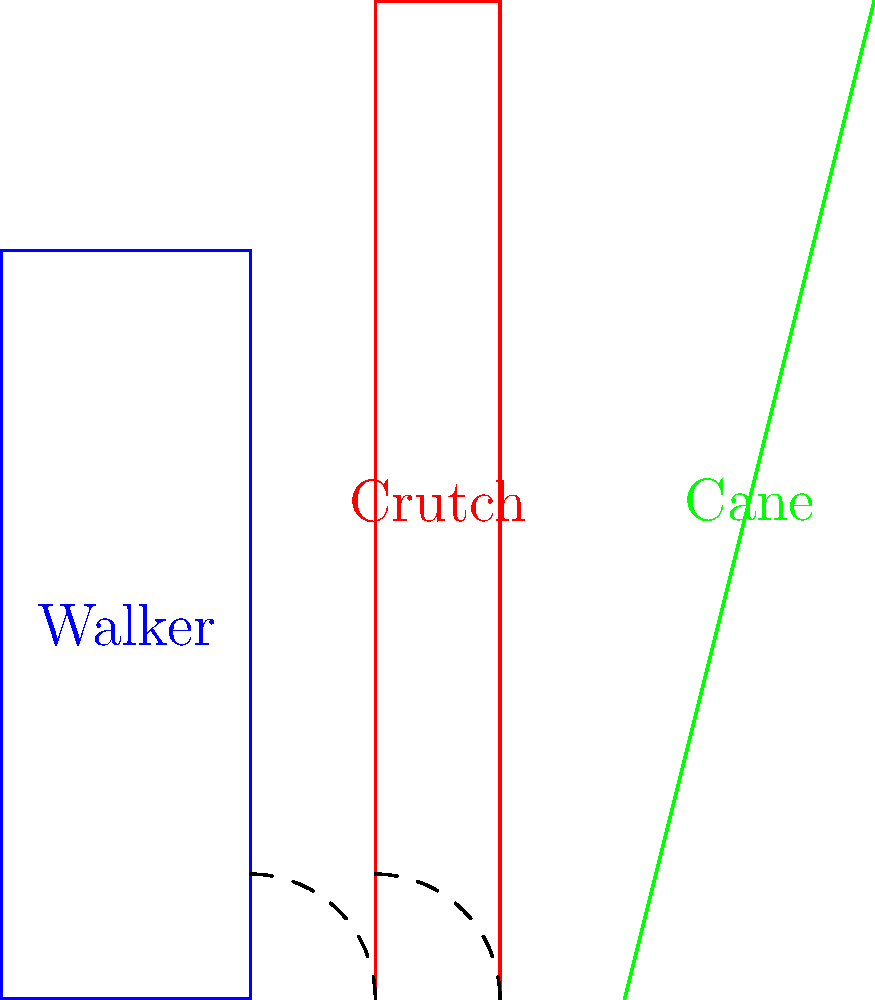Look at the picture of different walking aids. The walker and crutch both form 90-degree angles with the ground. What is the approximate angle that the cane makes with the ground? Let's approach this step-by-step:

1. We can see that the walker and crutch both form 90-degree angles with the ground. This gives us a reference for comparison.

2. The cane is leaning at an angle, which is less than 90 degrees.

3. To find the angle of the cane, we can use basic trigonometry. The cane forms a right-angled triangle with the ground.

4. In the diagram, the cane rises about 3 units for every 1 unit it goes across.

5. This ratio (3:1) corresponds to the tangent of the angle we're looking for.

6. We can calculate the angle using the arctangent function:
   $\theta = \arctan(\frac{3}{1}) \approx 71.57^\circ$

7. Rounding to the nearest whole number, we get 72°.

Therefore, the cane makes an angle of approximately 72° with the ground.
Answer: 72° 